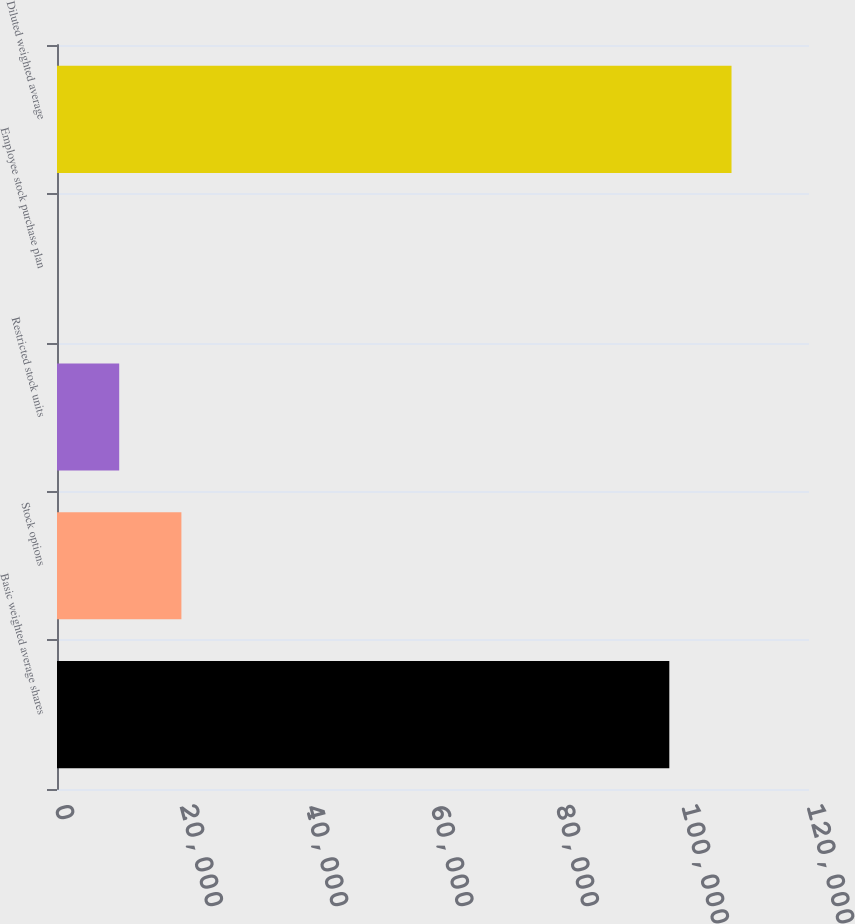Convert chart to OTSL. <chart><loc_0><loc_0><loc_500><loc_500><bar_chart><fcel>Basic weighted average shares<fcel>Stock options<fcel>Restricted stock units<fcel>Employee stock purchase plan<fcel>Diluted weighted average<nl><fcel>97710<fcel>19851.8<fcel>9926.9<fcel>2<fcel>107635<nl></chart> 